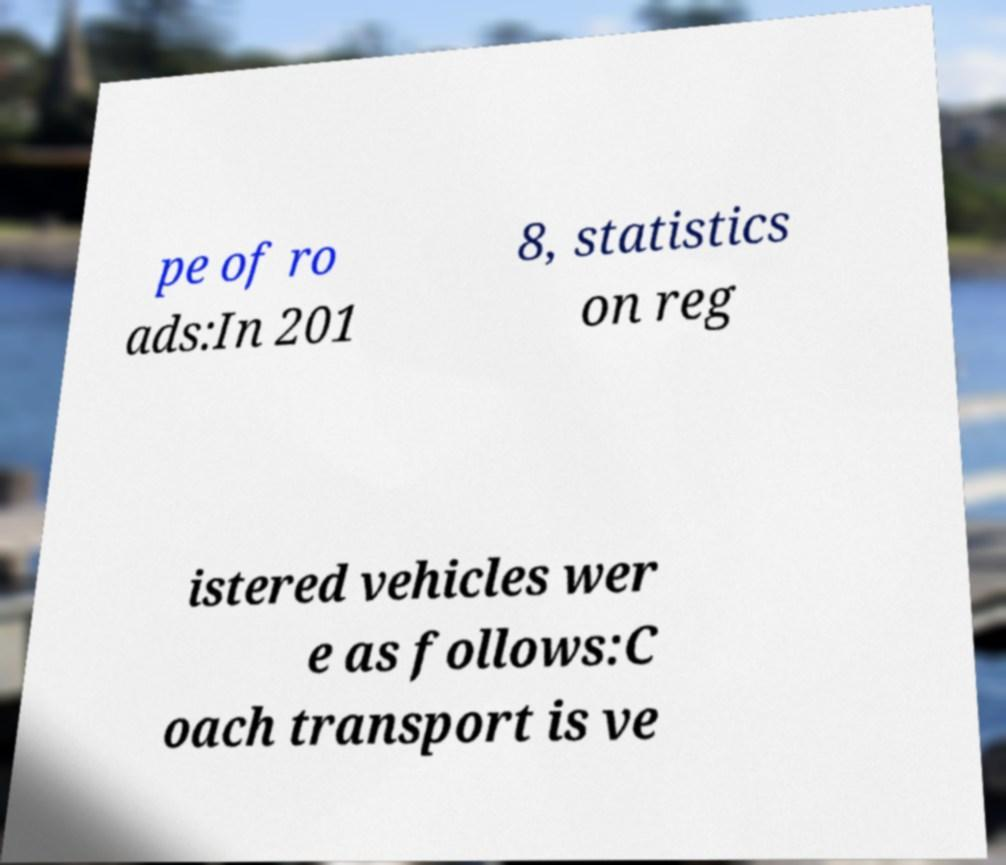Please identify and transcribe the text found in this image. pe of ro ads:In 201 8, statistics on reg istered vehicles wer e as follows:C oach transport is ve 